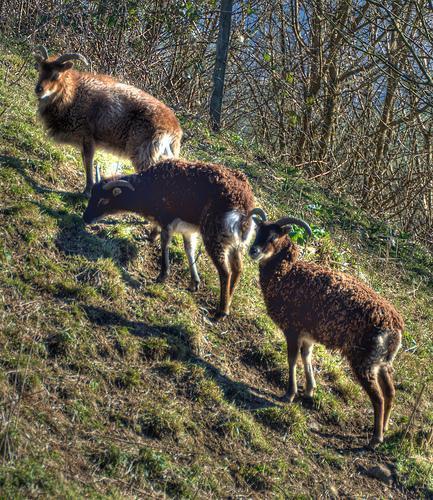How many goats are on the hill?
Give a very brief answer. 3. 